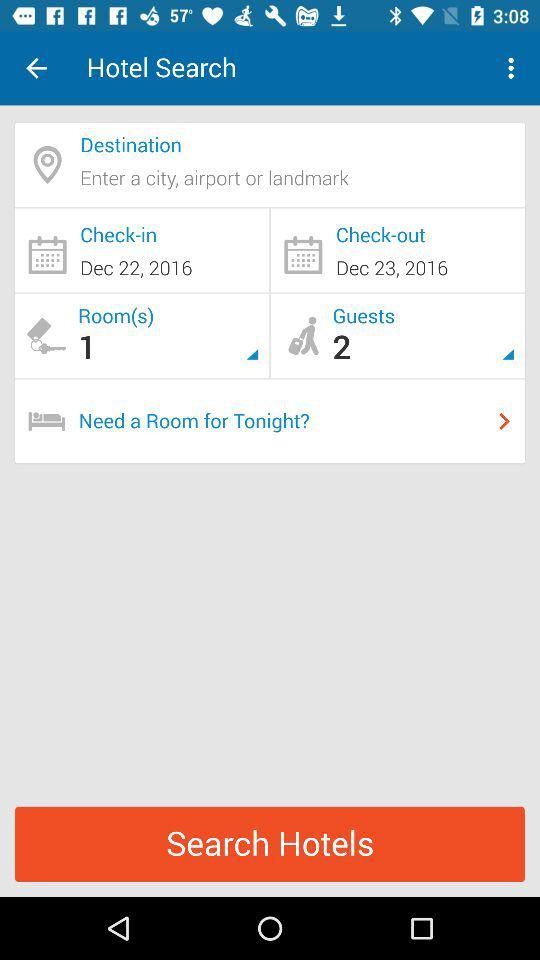How many guests are there? There are 2 guests. 